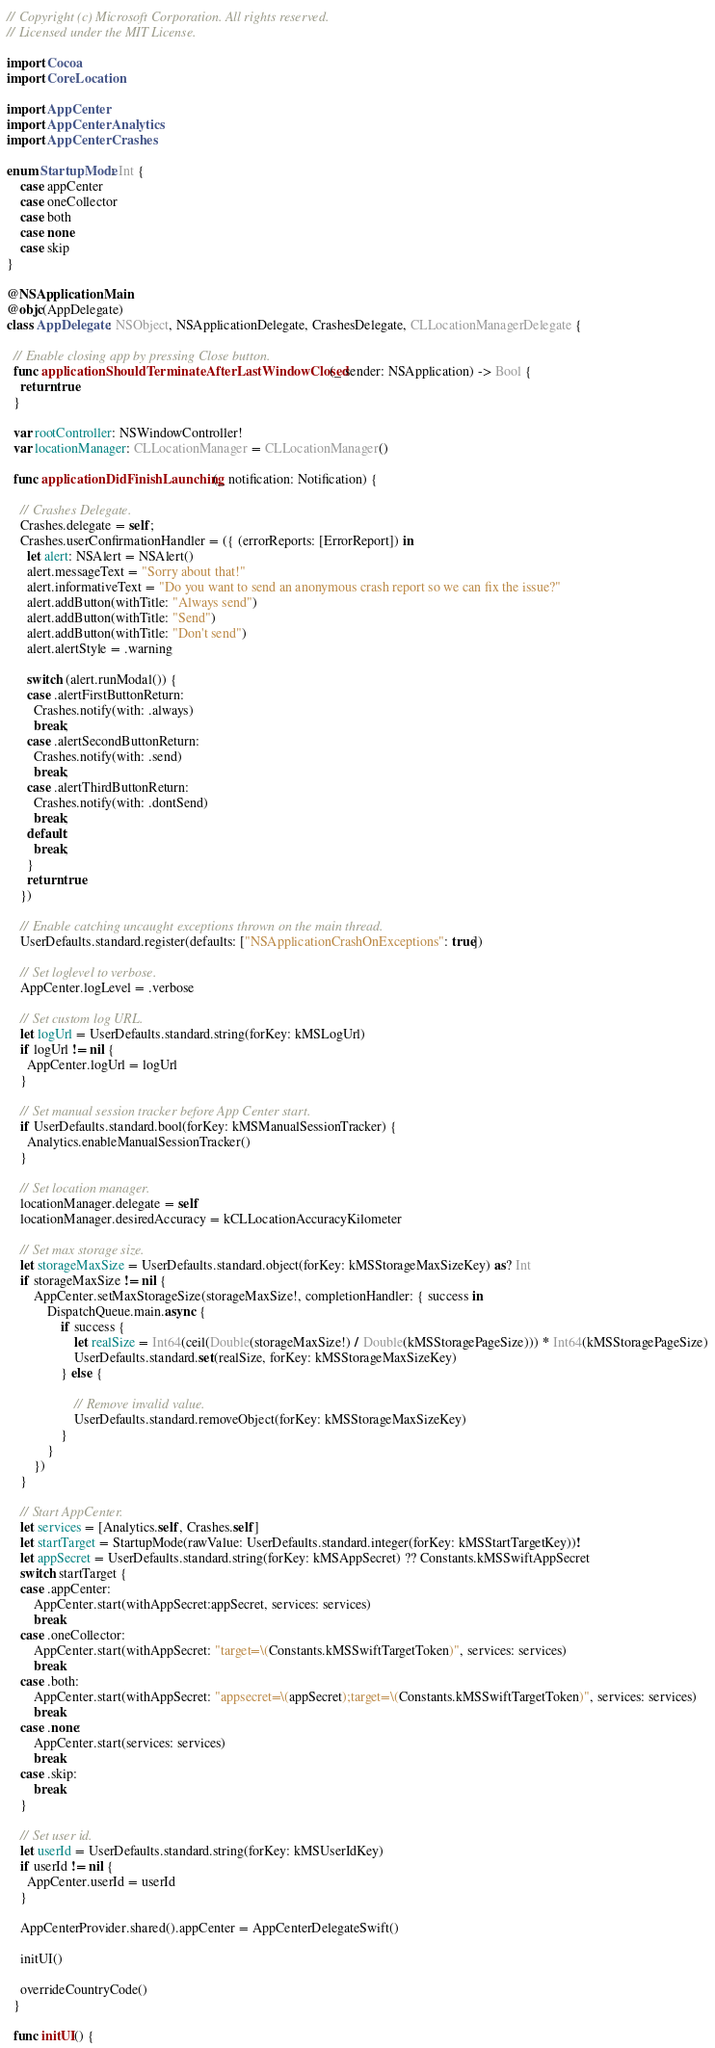Convert code to text. <code><loc_0><loc_0><loc_500><loc_500><_Swift_>// Copyright (c) Microsoft Corporation. All rights reserved.
// Licensed under the MIT License.

import Cocoa
import CoreLocation

import AppCenter
import AppCenterAnalytics
import AppCenterCrashes

enum StartupMode: Int {
    case appCenter
    case oneCollector
    case both
    case none
    case skip
}

@NSApplicationMain
@objc(AppDelegate)
class AppDelegate: NSObject, NSApplicationDelegate, CrashesDelegate, CLLocationManagerDelegate {

  // Enable closing app by pressing Close button.
  func applicationShouldTerminateAfterLastWindowClosed(_ sender: NSApplication) -> Bool {
    return true
  }

  var rootController: NSWindowController!
  var locationManager: CLLocationManager = CLLocationManager()
    
  func applicationDidFinishLaunching(_ notification: Notification) {
    
    // Crashes Delegate.
    Crashes.delegate = self;
    Crashes.userConfirmationHandler = ({ (errorReports: [ErrorReport]) in
      let alert: NSAlert = NSAlert()
      alert.messageText = "Sorry about that!"
      alert.informativeText = "Do you want to send an anonymous crash report so we can fix the issue?"
      alert.addButton(withTitle: "Always send")
      alert.addButton(withTitle: "Send")
      alert.addButton(withTitle: "Don't send")
      alert.alertStyle = .warning

      switch (alert.runModal()) {
      case .alertFirstButtonReturn:
        Crashes.notify(with: .always)
        break;
      case .alertSecondButtonReturn:
        Crashes.notify(with: .send)
        break;
      case .alertThirdButtonReturn:
        Crashes.notify(with: .dontSend)
        break;
      default:
        break;
      }
      return true
    })

    // Enable catching uncaught exceptions thrown on the main thread.
    UserDefaults.standard.register(defaults: ["NSApplicationCrashOnExceptions": true])

    // Set loglevel to verbose.
    AppCenter.logLevel = .verbose

    // Set custom log URL.
    let logUrl = UserDefaults.standard.string(forKey: kMSLogUrl)
    if logUrl != nil {
      AppCenter.logUrl = logUrl
    }
    
    // Set manual session tracker before App Center start.
    if UserDefaults.standard.bool(forKey: kMSManualSessionTracker) {
      Analytics.enableManualSessionTracker()
    }
    
    // Set location manager.
    locationManager.delegate = self
    locationManager.desiredAccuracy = kCLLocationAccuracyKilometer

    // Set max storage size.
    let storageMaxSize = UserDefaults.standard.object(forKey: kMSStorageMaxSizeKey) as? Int
    if storageMaxSize != nil {
        AppCenter.setMaxStorageSize(storageMaxSize!, completionHandler: { success in
            DispatchQueue.main.async {
                if success {
                    let realSize = Int64(ceil(Double(storageMaxSize!) / Double(kMSStoragePageSize))) * Int64(kMSStoragePageSize)
                    UserDefaults.standard.set(realSize, forKey: kMSStorageMaxSizeKey)
                } else {
                    
                    // Remove invalid value.
                    UserDefaults.standard.removeObject(forKey: kMSStorageMaxSizeKey)
                }
            }
        })
    }

    // Start AppCenter.
    let services = [Analytics.self, Crashes.self]
    let startTarget = StartupMode(rawValue: UserDefaults.standard.integer(forKey: kMSStartTargetKey))!
    let appSecret = UserDefaults.standard.string(forKey: kMSAppSecret) ?? Constants.kMSSwiftAppSecret
    switch startTarget {
    case .appCenter:
        AppCenter.start(withAppSecret:appSecret, services: services)
        break
    case .oneCollector:
        AppCenter.start(withAppSecret: "target=\(Constants.kMSSwiftTargetToken)", services: services)
        break
    case .both:
        AppCenter.start(withAppSecret: "appsecret=\(appSecret);target=\(Constants.kMSSwiftTargetToken)", services: services)
        break
    case .none:
        AppCenter.start(services: services)
        break
    case .skip:
        break
    }
      
    // Set user id.
    let userId = UserDefaults.standard.string(forKey: kMSUserIdKey)
    if userId != nil {
      AppCenter.userId = userId
    }

    AppCenterProvider.shared().appCenter = AppCenterDelegateSwift()

    initUI()

    overrideCountryCode()
  }

  func initUI() {</code> 